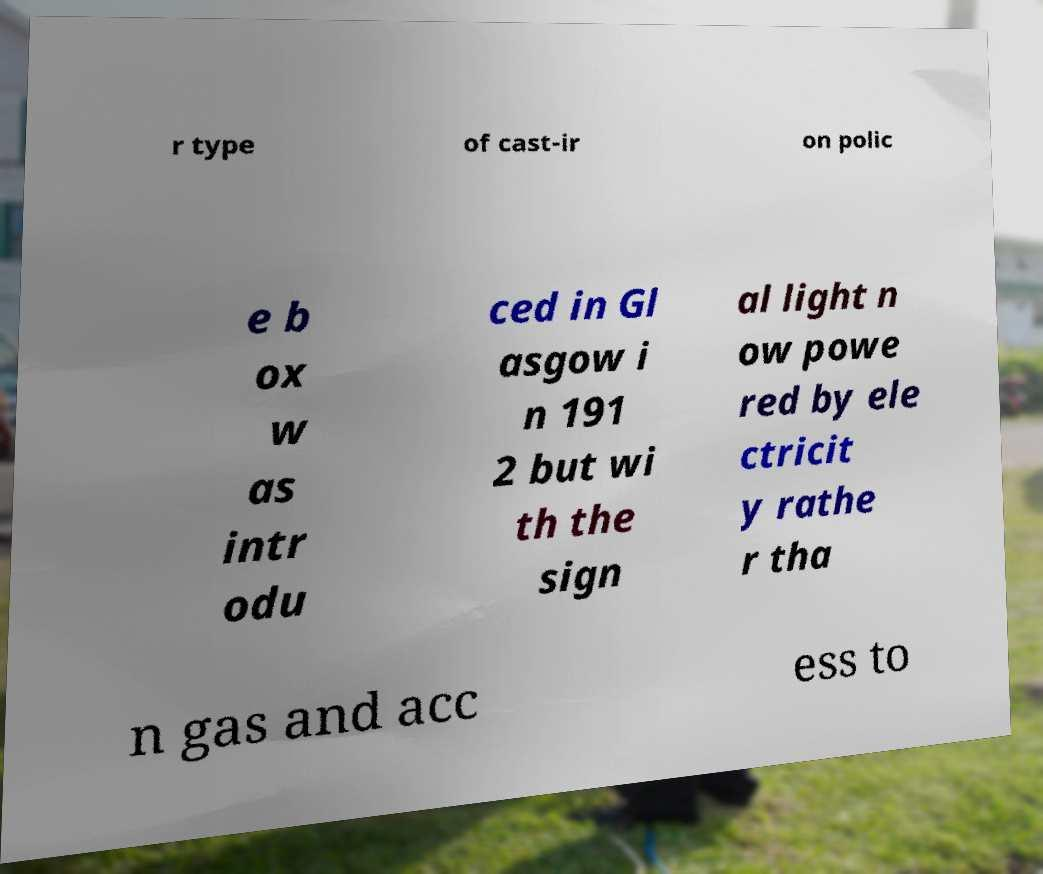What messages or text are displayed in this image? I need them in a readable, typed format. r type of cast-ir on polic e b ox w as intr odu ced in Gl asgow i n 191 2 but wi th the sign al light n ow powe red by ele ctricit y rathe r tha n gas and acc ess to 